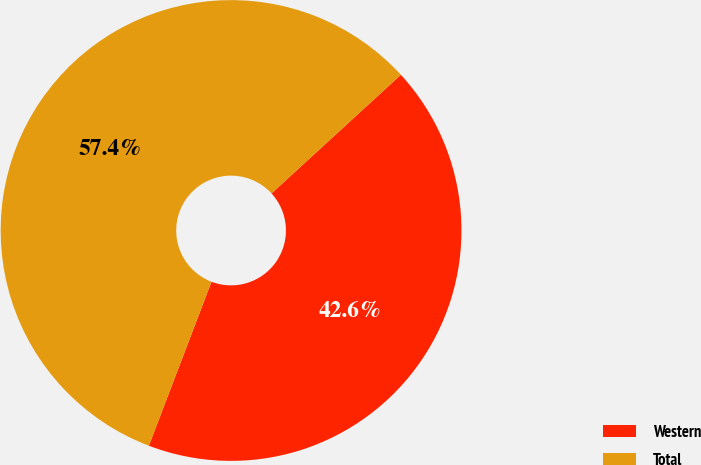Convert chart to OTSL. <chart><loc_0><loc_0><loc_500><loc_500><pie_chart><fcel>Western<fcel>Total<nl><fcel>42.62%<fcel>57.38%<nl></chart> 